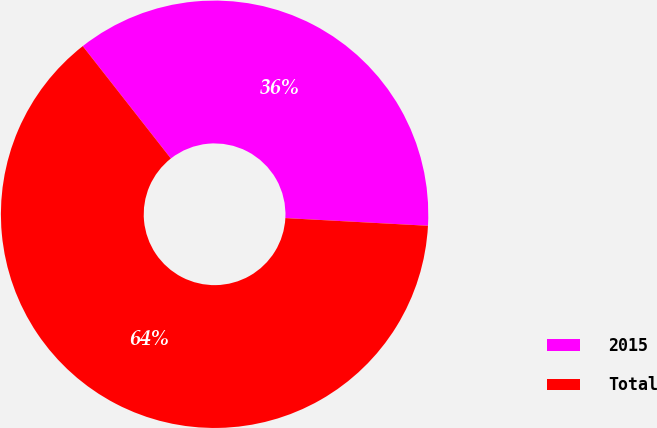Convert chart. <chart><loc_0><loc_0><loc_500><loc_500><pie_chart><fcel>2015<fcel>Total<nl><fcel>36.44%<fcel>63.56%<nl></chart> 